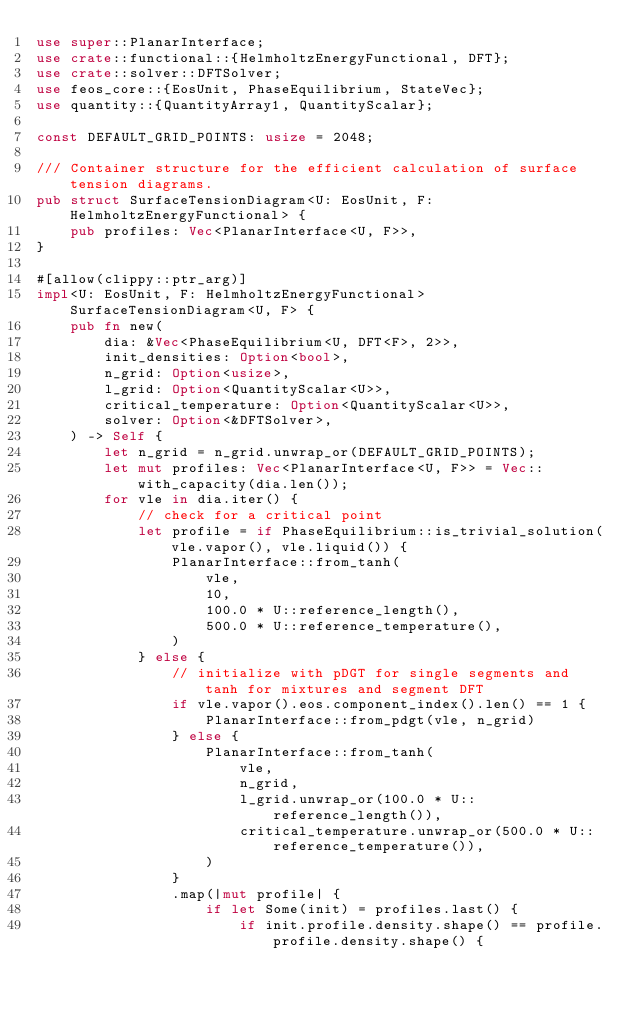<code> <loc_0><loc_0><loc_500><loc_500><_Rust_>use super::PlanarInterface;
use crate::functional::{HelmholtzEnergyFunctional, DFT};
use crate::solver::DFTSolver;
use feos_core::{EosUnit, PhaseEquilibrium, StateVec};
use quantity::{QuantityArray1, QuantityScalar};

const DEFAULT_GRID_POINTS: usize = 2048;

/// Container structure for the efficient calculation of surface tension diagrams.
pub struct SurfaceTensionDiagram<U: EosUnit, F: HelmholtzEnergyFunctional> {
    pub profiles: Vec<PlanarInterface<U, F>>,
}

#[allow(clippy::ptr_arg)]
impl<U: EosUnit, F: HelmholtzEnergyFunctional> SurfaceTensionDiagram<U, F> {
    pub fn new(
        dia: &Vec<PhaseEquilibrium<U, DFT<F>, 2>>,
        init_densities: Option<bool>,
        n_grid: Option<usize>,
        l_grid: Option<QuantityScalar<U>>,
        critical_temperature: Option<QuantityScalar<U>>,
        solver: Option<&DFTSolver>,
    ) -> Self {
        let n_grid = n_grid.unwrap_or(DEFAULT_GRID_POINTS);
        let mut profiles: Vec<PlanarInterface<U, F>> = Vec::with_capacity(dia.len());
        for vle in dia.iter() {
            // check for a critical point
            let profile = if PhaseEquilibrium::is_trivial_solution(vle.vapor(), vle.liquid()) {
                PlanarInterface::from_tanh(
                    vle,
                    10,
                    100.0 * U::reference_length(),
                    500.0 * U::reference_temperature(),
                )
            } else {
                // initialize with pDGT for single segments and tanh for mixtures and segment DFT
                if vle.vapor().eos.component_index().len() == 1 {
                    PlanarInterface::from_pdgt(vle, n_grid)
                } else {
                    PlanarInterface::from_tanh(
                        vle,
                        n_grid,
                        l_grid.unwrap_or(100.0 * U::reference_length()),
                        critical_temperature.unwrap_or(500.0 * U::reference_temperature()),
                    )
                }
                .map(|mut profile| {
                    if let Some(init) = profiles.last() {
                        if init.profile.density.shape() == profile.profile.density.shape() {</code> 